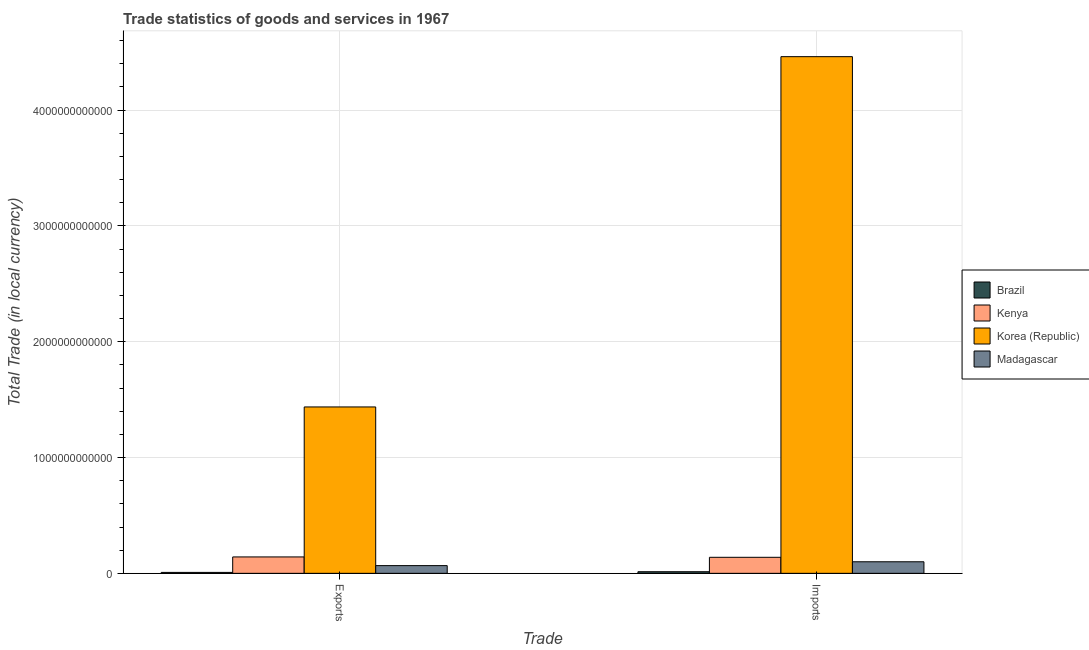How many different coloured bars are there?
Your answer should be very brief. 4. Are the number of bars per tick equal to the number of legend labels?
Offer a terse response. Yes. Are the number of bars on each tick of the X-axis equal?
Provide a succinct answer. Yes. How many bars are there on the 2nd tick from the right?
Make the answer very short. 4. What is the label of the 1st group of bars from the left?
Provide a succinct answer. Exports. What is the imports of goods and services in Korea (Republic)?
Give a very brief answer. 4.46e+12. Across all countries, what is the maximum imports of goods and services?
Offer a terse response. 4.46e+12. Across all countries, what is the minimum export of goods and services?
Your answer should be compact. 8.01e+09. In which country was the imports of goods and services minimum?
Give a very brief answer. Brazil. What is the total imports of goods and services in the graph?
Provide a succinct answer. 4.71e+12. What is the difference between the export of goods and services in Korea (Republic) and that in Brazil?
Make the answer very short. 1.43e+12. What is the difference between the imports of goods and services in Korea (Republic) and the export of goods and services in Brazil?
Make the answer very short. 4.45e+12. What is the average imports of goods and services per country?
Your answer should be very brief. 1.18e+12. What is the difference between the imports of goods and services and export of goods and services in Kenya?
Provide a succinct answer. -3.24e+09. In how many countries, is the imports of goods and services greater than 600000000000 LCU?
Provide a short and direct response. 1. What is the ratio of the export of goods and services in Kenya to that in Brazil?
Provide a succinct answer. 17.7. What does the 4th bar from the left in Exports represents?
Ensure brevity in your answer.  Madagascar. What does the 1st bar from the right in Imports represents?
Offer a terse response. Madagascar. Are all the bars in the graph horizontal?
Your answer should be very brief. No. How many countries are there in the graph?
Offer a very short reply. 4. What is the difference between two consecutive major ticks on the Y-axis?
Your answer should be very brief. 1.00e+12. Does the graph contain grids?
Provide a short and direct response. Yes. How are the legend labels stacked?
Ensure brevity in your answer.  Vertical. What is the title of the graph?
Your response must be concise. Trade statistics of goods and services in 1967. What is the label or title of the X-axis?
Offer a very short reply. Trade. What is the label or title of the Y-axis?
Ensure brevity in your answer.  Total Trade (in local currency). What is the Total Trade (in local currency) in Brazil in Exports?
Ensure brevity in your answer.  8.01e+09. What is the Total Trade (in local currency) of Kenya in Exports?
Your answer should be compact. 1.42e+11. What is the Total Trade (in local currency) of Korea (Republic) in Exports?
Make the answer very short. 1.44e+12. What is the Total Trade (in local currency) of Madagascar in Exports?
Your response must be concise. 6.66e+1. What is the Total Trade (in local currency) of Brazil in Imports?
Offer a very short reply. 1.39e+1. What is the Total Trade (in local currency) in Kenya in Imports?
Your answer should be very brief. 1.38e+11. What is the Total Trade (in local currency) of Korea (Republic) in Imports?
Your answer should be very brief. 4.46e+12. What is the Total Trade (in local currency) of Madagascar in Imports?
Ensure brevity in your answer.  9.98e+1. Across all Trade, what is the maximum Total Trade (in local currency) in Brazil?
Provide a succinct answer. 1.39e+1. Across all Trade, what is the maximum Total Trade (in local currency) of Kenya?
Ensure brevity in your answer.  1.42e+11. Across all Trade, what is the maximum Total Trade (in local currency) of Korea (Republic)?
Keep it short and to the point. 4.46e+12. Across all Trade, what is the maximum Total Trade (in local currency) of Madagascar?
Offer a terse response. 9.98e+1. Across all Trade, what is the minimum Total Trade (in local currency) in Brazil?
Your answer should be very brief. 8.01e+09. Across all Trade, what is the minimum Total Trade (in local currency) in Kenya?
Make the answer very short. 1.38e+11. Across all Trade, what is the minimum Total Trade (in local currency) in Korea (Republic)?
Your answer should be very brief. 1.44e+12. Across all Trade, what is the minimum Total Trade (in local currency) in Madagascar?
Give a very brief answer. 6.66e+1. What is the total Total Trade (in local currency) in Brazil in the graph?
Provide a short and direct response. 2.19e+1. What is the total Total Trade (in local currency) of Kenya in the graph?
Provide a succinct answer. 2.80e+11. What is the total Total Trade (in local currency) of Korea (Republic) in the graph?
Ensure brevity in your answer.  5.90e+12. What is the total Total Trade (in local currency) of Madagascar in the graph?
Ensure brevity in your answer.  1.66e+11. What is the difference between the Total Trade (in local currency) of Brazil in Exports and that in Imports?
Your answer should be compact. -5.86e+09. What is the difference between the Total Trade (in local currency) of Kenya in Exports and that in Imports?
Ensure brevity in your answer.  3.24e+09. What is the difference between the Total Trade (in local currency) in Korea (Republic) in Exports and that in Imports?
Provide a succinct answer. -3.02e+12. What is the difference between the Total Trade (in local currency) of Madagascar in Exports and that in Imports?
Your response must be concise. -3.32e+1. What is the difference between the Total Trade (in local currency) of Brazil in Exports and the Total Trade (in local currency) of Kenya in Imports?
Keep it short and to the point. -1.30e+11. What is the difference between the Total Trade (in local currency) of Brazil in Exports and the Total Trade (in local currency) of Korea (Republic) in Imports?
Your response must be concise. -4.45e+12. What is the difference between the Total Trade (in local currency) in Brazil in Exports and the Total Trade (in local currency) in Madagascar in Imports?
Make the answer very short. -9.18e+1. What is the difference between the Total Trade (in local currency) in Kenya in Exports and the Total Trade (in local currency) in Korea (Republic) in Imports?
Provide a succinct answer. -4.32e+12. What is the difference between the Total Trade (in local currency) of Kenya in Exports and the Total Trade (in local currency) of Madagascar in Imports?
Make the answer very short. 4.19e+1. What is the difference between the Total Trade (in local currency) of Korea (Republic) in Exports and the Total Trade (in local currency) of Madagascar in Imports?
Offer a terse response. 1.34e+12. What is the average Total Trade (in local currency) of Brazil per Trade?
Keep it short and to the point. 1.09e+1. What is the average Total Trade (in local currency) in Kenya per Trade?
Your answer should be compact. 1.40e+11. What is the average Total Trade (in local currency) of Korea (Republic) per Trade?
Your answer should be very brief. 2.95e+12. What is the average Total Trade (in local currency) in Madagascar per Trade?
Ensure brevity in your answer.  8.32e+1. What is the difference between the Total Trade (in local currency) in Brazil and Total Trade (in local currency) in Kenya in Exports?
Offer a very short reply. -1.34e+11. What is the difference between the Total Trade (in local currency) in Brazil and Total Trade (in local currency) in Korea (Republic) in Exports?
Your answer should be very brief. -1.43e+12. What is the difference between the Total Trade (in local currency) of Brazil and Total Trade (in local currency) of Madagascar in Exports?
Your answer should be very brief. -5.85e+1. What is the difference between the Total Trade (in local currency) in Kenya and Total Trade (in local currency) in Korea (Republic) in Exports?
Offer a terse response. -1.29e+12. What is the difference between the Total Trade (in local currency) in Kenya and Total Trade (in local currency) in Madagascar in Exports?
Keep it short and to the point. 7.51e+1. What is the difference between the Total Trade (in local currency) in Korea (Republic) and Total Trade (in local currency) in Madagascar in Exports?
Keep it short and to the point. 1.37e+12. What is the difference between the Total Trade (in local currency) of Brazil and Total Trade (in local currency) of Kenya in Imports?
Your answer should be compact. -1.25e+11. What is the difference between the Total Trade (in local currency) of Brazil and Total Trade (in local currency) of Korea (Republic) in Imports?
Offer a terse response. -4.45e+12. What is the difference between the Total Trade (in local currency) of Brazil and Total Trade (in local currency) of Madagascar in Imports?
Offer a very short reply. -8.59e+1. What is the difference between the Total Trade (in local currency) of Kenya and Total Trade (in local currency) of Korea (Republic) in Imports?
Provide a short and direct response. -4.32e+12. What is the difference between the Total Trade (in local currency) of Kenya and Total Trade (in local currency) of Madagascar in Imports?
Keep it short and to the point. 3.87e+1. What is the difference between the Total Trade (in local currency) in Korea (Republic) and Total Trade (in local currency) in Madagascar in Imports?
Offer a very short reply. 4.36e+12. What is the ratio of the Total Trade (in local currency) of Brazil in Exports to that in Imports?
Your response must be concise. 0.58. What is the ratio of the Total Trade (in local currency) in Kenya in Exports to that in Imports?
Your answer should be very brief. 1.02. What is the ratio of the Total Trade (in local currency) in Korea (Republic) in Exports to that in Imports?
Provide a succinct answer. 0.32. What is the ratio of the Total Trade (in local currency) of Madagascar in Exports to that in Imports?
Provide a succinct answer. 0.67. What is the difference between the highest and the second highest Total Trade (in local currency) of Brazil?
Give a very brief answer. 5.86e+09. What is the difference between the highest and the second highest Total Trade (in local currency) of Kenya?
Make the answer very short. 3.24e+09. What is the difference between the highest and the second highest Total Trade (in local currency) of Korea (Republic)?
Your response must be concise. 3.02e+12. What is the difference between the highest and the second highest Total Trade (in local currency) of Madagascar?
Your answer should be very brief. 3.32e+1. What is the difference between the highest and the lowest Total Trade (in local currency) in Brazil?
Your response must be concise. 5.86e+09. What is the difference between the highest and the lowest Total Trade (in local currency) in Kenya?
Make the answer very short. 3.24e+09. What is the difference between the highest and the lowest Total Trade (in local currency) in Korea (Republic)?
Your response must be concise. 3.02e+12. What is the difference between the highest and the lowest Total Trade (in local currency) of Madagascar?
Your answer should be compact. 3.32e+1. 